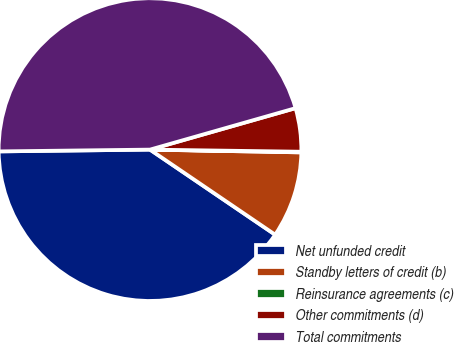Convert chart. <chart><loc_0><loc_0><loc_500><loc_500><pie_chart><fcel>Net unfunded credit<fcel>Standby letters of credit (b)<fcel>Reinsurance agreements (c)<fcel>Other commitments (d)<fcel>Total commitments<nl><fcel>40.31%<fcel>9.21%<fcel>0.07%<fcel>4.64%<fcel>45.77%<nl></chart> 